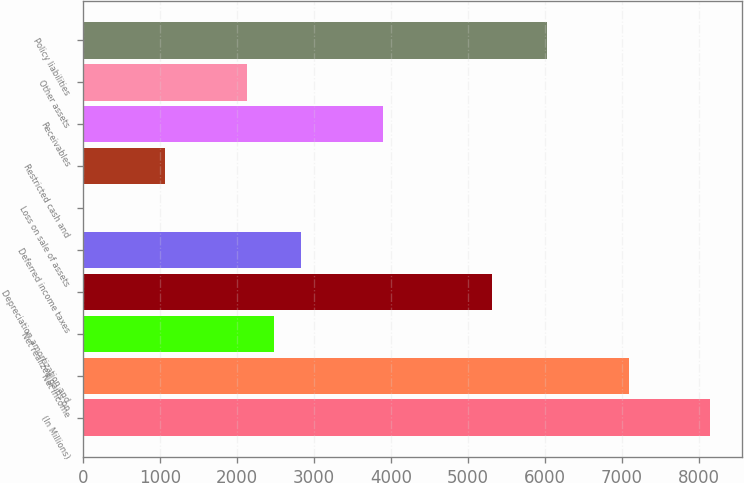Convert chart to OTSL. <chart><loc_0><loc_0><loc_500><loc_500><bar_chart><fcel>(In Millions)<fcel>Net income<fcel>Net realized gains on<fcel>Depreciation amortization and<fcel>Deferred income taxes<fcel>Loss on sale of assets<fcel>Restricted cash and<fcel>Receivables<fcel>Other assets<fcel>Policy liabilities<nl><fcel>8152.39<fcel>7089.1<fcel>2481.51<fcel>5316.95<fcel>2835.94<fcel>0.5<fcel>1063.79<fcel>3899.23<fcel>2127.08<fcel>6025.81<nl></chart> 